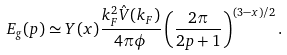<formula> <loc_0><loc_0><loc_500><loc_500>E _ { g } ( p ) \simeq Y ( x ) \frac { k _ { F } ^ { 2 } \hat { V } ( k _ { F } ) } { 4 \pi \phi } \left ( \frac { 2 \pi } { 2 p + 1 } \right ) ^ { ( 3 - x ) / 2 } .</formula> 